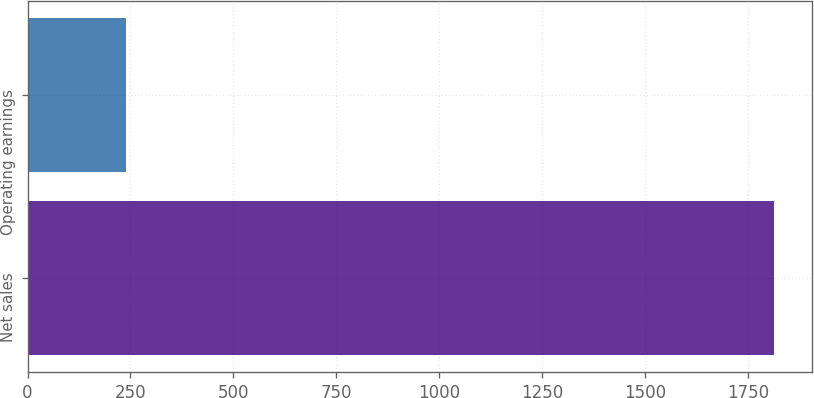Convert chart to OTSL. <chart><loc_0><loc_0><loc_500><loc_500><bar_chart><fcel>Net sales<fcel>Operating earnings<nl><fcel>1814<fcel>239<nl></chart> 